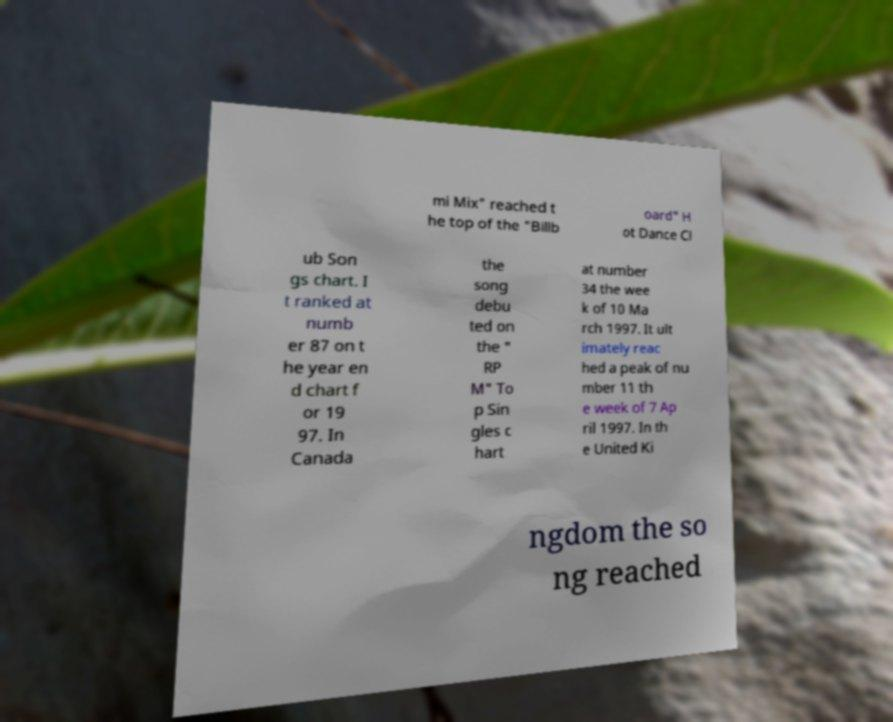Can you read and provide the text displayed in the image?This photo seems to have some interesting text. Can you extract and type it out for me? mi Mix" reached t he top of the "Billb oard" H ot Dance Cl ub Son gs chart. I t ranked at numb er 87 on t he year en d chart f or 19 97. In Canada the song debu ted on the " RP M" To p Sin gles c hart at number 34 the wee k of 10 Ma rch 1997. It ult imately reac hed a peak of nu mber 11 th e week of 7 Ap ril 1997. In th e United Ki ngdom the so ng reached 